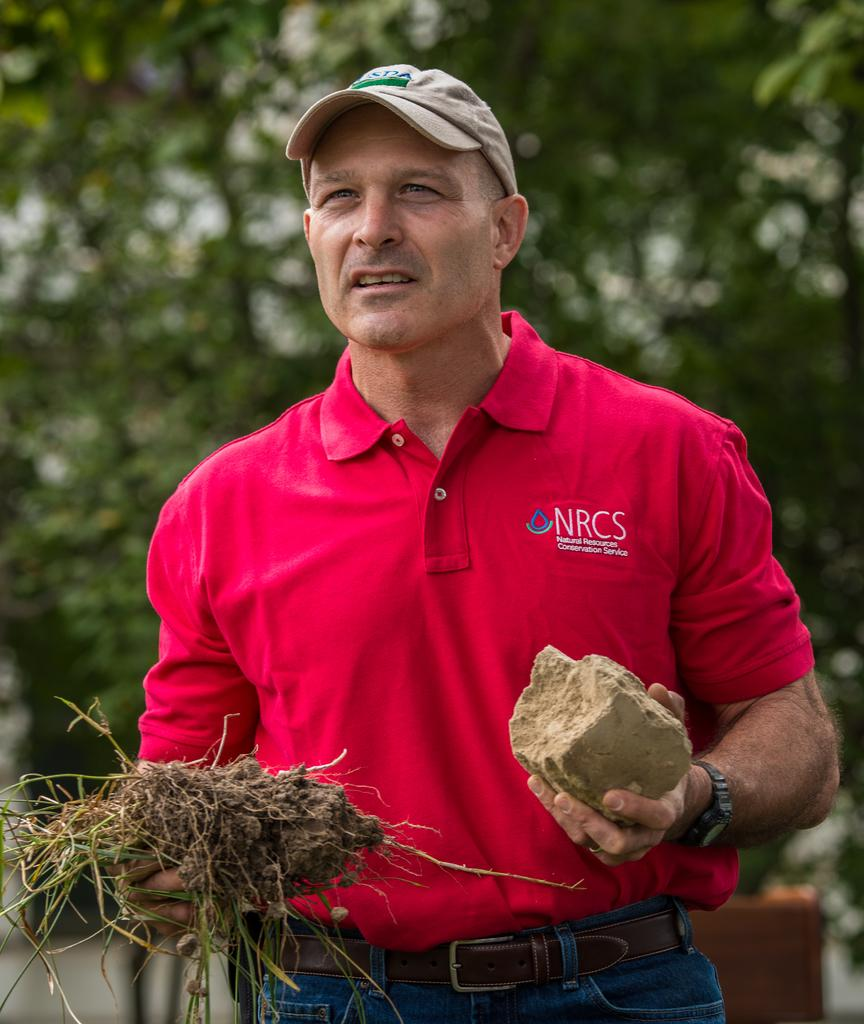Who or what is present in the image? There is a person in the image. What is the person holding in the image? The person is holding a stone. What type of vegetation can be seen in the image? There is grass visible in the image. What can be seen in the distance in the image? There are trees in the background of the image. What type of doll is sitting on the hand in the image? There is no doll or hand present in the image. Can you describe the type of berry that the person is holding in the image? The person is not holding a berry in the image; they are holding a stone. 